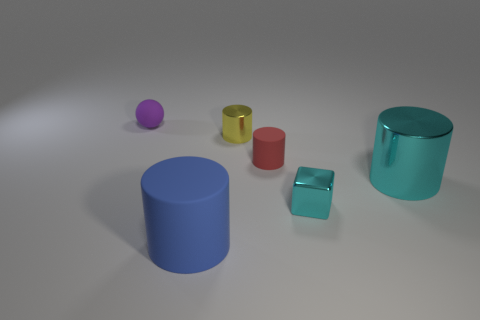Subtract 1 cylinders. How many cylinders are left? 3 Add 1 big cubes. How many objects exist? 7 Subtract all blocks. How many objects are left? 5 Subtract all cylinders. Subtract all small cyan matte cylinders. How many objects are left? 2 Add 3 large cyan metallic objects. How many large cyan metallic objects are left? 4 Add 5 large cyan cylinders. How many large cyan cylinders exist? 6 Subtract 0 red spheres. How many objects are left? 6 